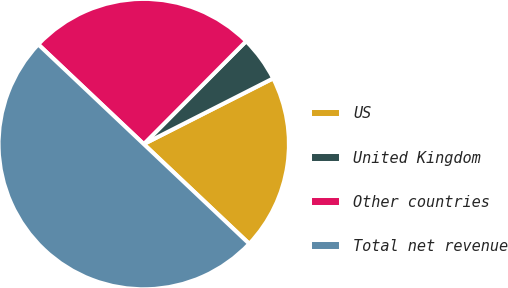<chart> <loc_0><loc_0><loc_500><loc_500><pie_chart><fcel>US<fcel>United Kingdom<fcel>Other countries<fcel>Total net revenue<nl><fcel>19.53%<fcel>5.06%<fcel>25.41%<fcel>50.0%<nl></chart> 